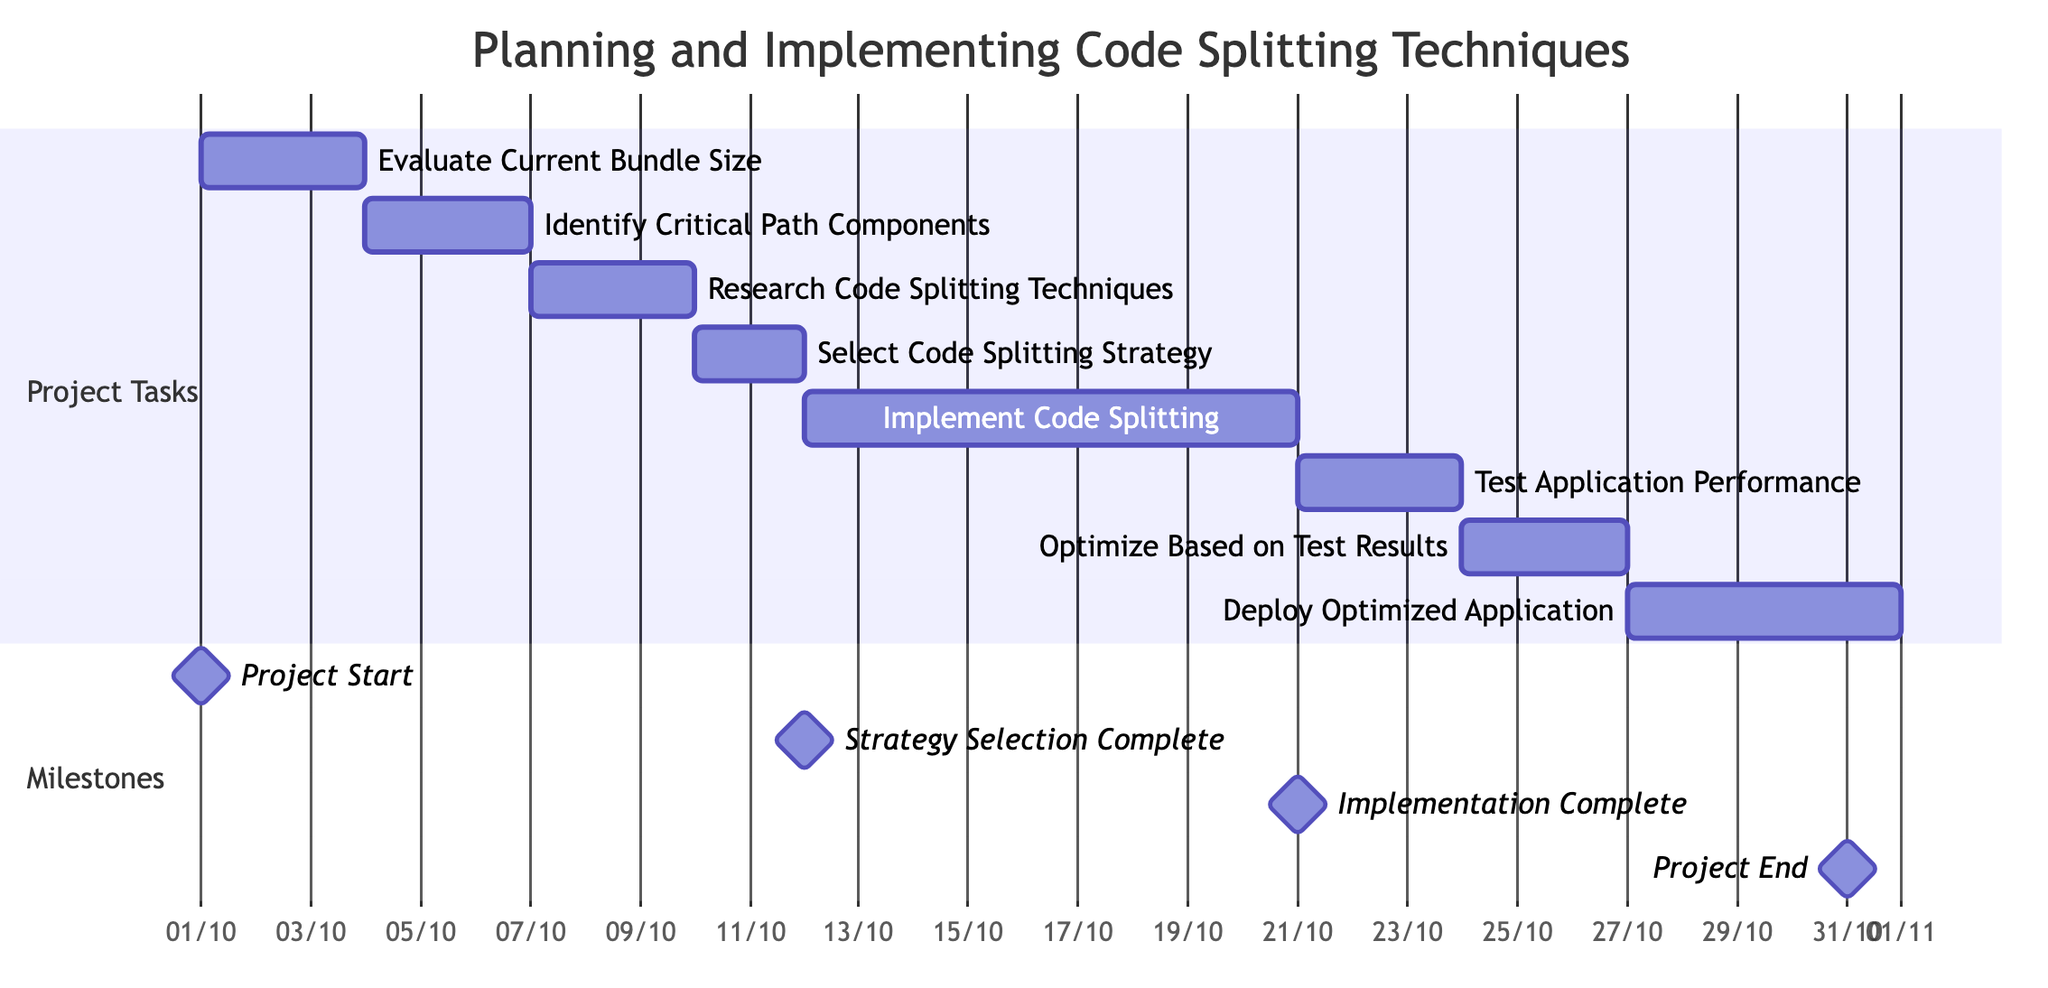What is the total duration of the project? The project starts on October 1, 2023 and ends on October 31, 2023. To find the total duration, calculate the difference between the start and end dates: October 31 minus October 1 gives 30 days.
Answer: 30 days Which task immediately follows "Research Code Splitting Techniques"? In the Gantt chart, the task that comes directly after "Research Code Splitting Techniques" is "Select Code Splitting Strategy". This is established by looking at the sequencing of tasks indicated by the arrows in the chart.
Answer: Select Code Splitting Strategy How many tasks are listed in the Gantt chart? Reviewing the Gantt chart, seven distinct tasks are present: Evaluate Current Bundle Size, Identify Critical Path Components, Research Code Splitting Techniques, Select Code Splitting Strategy, Implement Code Splitting, Test Application for Performance Improvement, and Optimize Further Based on Test Results, leading to a total of eight tasks.
Answer: 8 tasks What is the start date for the "Implement Code Splitting" task? According to the diagram, the "Implement Code Splitting" task starts immediately after "Select Code Splitting Strategy". Since "Select Code Splitting Strategy" ends on October 11, 2023, "Implement Code Splitting" starts on October 12, 2023.
Answer: October 12, 2023 Which milestone occurs after the "Select Code Splitting Strategy"? The timeline indicates that the milestone occurring after the "Select Code Splitting Strategy" is "Strategy Selection Complete", aligning with the progress of tasks in the Gantt chart.
Answer: Strategy Selection Complete What is the duration of the "Test Application for Performance Improvement" task? The duration for the task "Test Application for Performance Improvement" is indicated in the Gantt chart as 3 days. By checking the details of that specific task, we identify its duration.
Answer: 3 days When will the "Deploy Optimized Application" task conclude? The "Deploy Optimized Application" task starts on October 27, 2023, and runs for 5 days. To find the conclusion date, add 5 days to the start date: October 31, 2023 marks its end.
Answer: October 31, 2023 Is "Optimize Further Based on Test Results" dependent on any previous task? Yes, the task "Optimize Further Based on Test Results" depends on the completion of "Test Application for Performance Improvement", as indicated by the dependencies in the Gantt chart.
Answer: Yes 